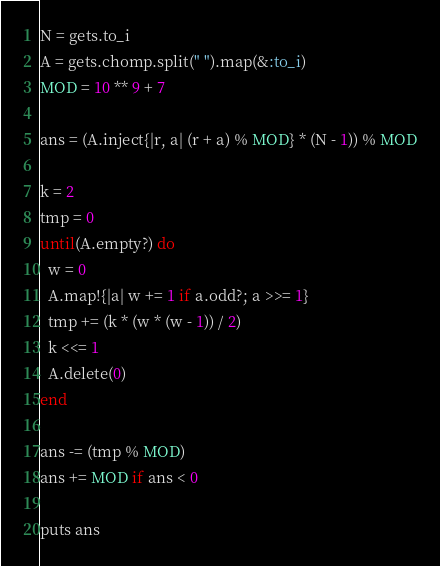<code> <loc_0><loc_0><loc_500><loc_500><_Ruby_>N = gets.to_i
A = gets.chomp.split(" ").map(&:to_i)
MOD = 10 ** 9 + 7

ans = (A.inject{|r, a| (r + a) % MOD} * (N - 1)) % MOD

k = 2
tmp = 0
until(A.empty?) do
  w = 0
  A.map!{|a| w += 1 if a.odd?; a >>= 1}
  tmp += (k * (w * (w - 1)) / 2)
  k <<= 1
  A.delete(0)
end

ans -= (tmp % MOD)
ans += MOD if ans < 0

puts ans
</code> 